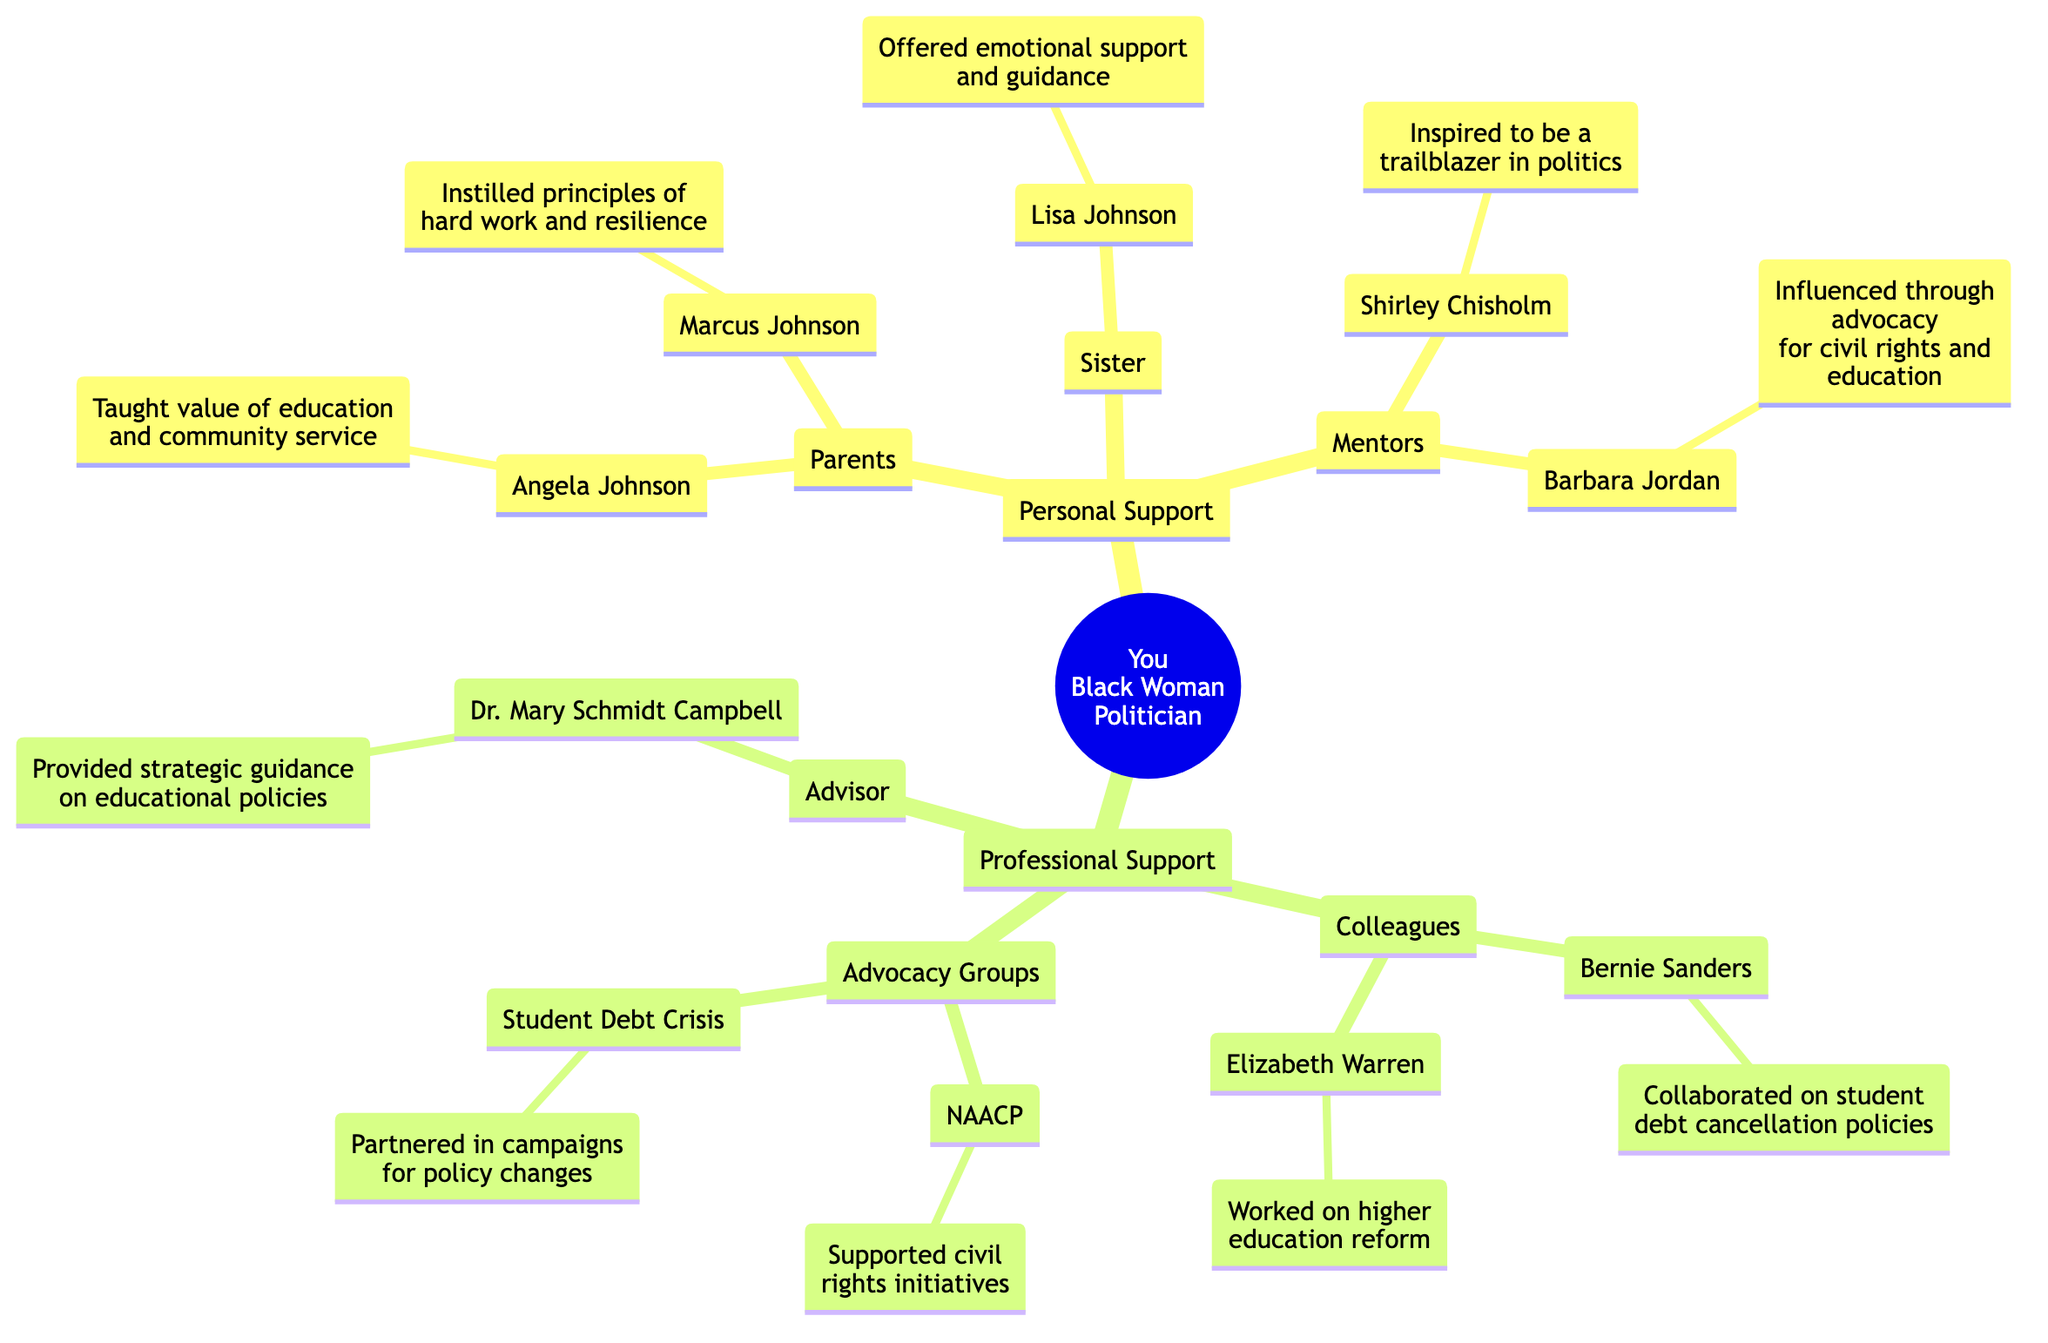What is the name of your mother? The diagram shows the node under "Parents" where the mother's name is provided. The node states "Angela Johnson," indicating that she is the mother.
Answer: Angela Johnson How many siblings do you have? The diagram under "siblings" lists only one person, "Lisa Johnson," which indicates that there is one sibling. Therefore, the count is one.
Answer: 1 Who is your political mentor? The diagram includes a section labeled "Mentors" where "Shirley Chisholm" is listed as a political mentor. This indicates her influence on your politcal journey.
Answer: Shirley Chisholm What influence did your father have? The diagram summarizes the father's influence under the node "Marcus Johnson," stating he "Instilled principles of hard work and resilience." This provides insight into his role in your upbringing.
Answer: Instilled principles of hard work and resilience Which advocacy group focuses on civil rights initiatives? In the "Advocacy Groups" section of the diagram, "NAACP" is specifically mentioned as the group that supported civil rights initiatives, making them the answer to this question.
Answer: NAACP How did Bernie Sanders contribute to your support network? The diagram under "Colleagues" mentions that "Bernie Sanders" collaborated on "student debt cancellation policies." This shows his contribution to your supportive professional network.
Answer: Collaborated on student debt cancellation policies How many mentors are listed? Counting the entries in the "Mentors" section of the diagram reveals two individuals: "Shirley Chisholm" and "Barbara Jordan," yielding a total of two mentors.
Answer: 2 Who is your advisor? The diagram includes an "Advisor" section where "Dr. Mary Schmidt Campbell" is mentioned. This indicates her role as an advisor in your professional network.
Answer: Dr. Mary Schmidt Campbell What type of support did Lisa Johnson provide? The diagram describes Lisa Johnson as having "Offered emotional support and guidance through political career," which indicates the type of support she provided.
Answer: Offered emotional support and guidance 